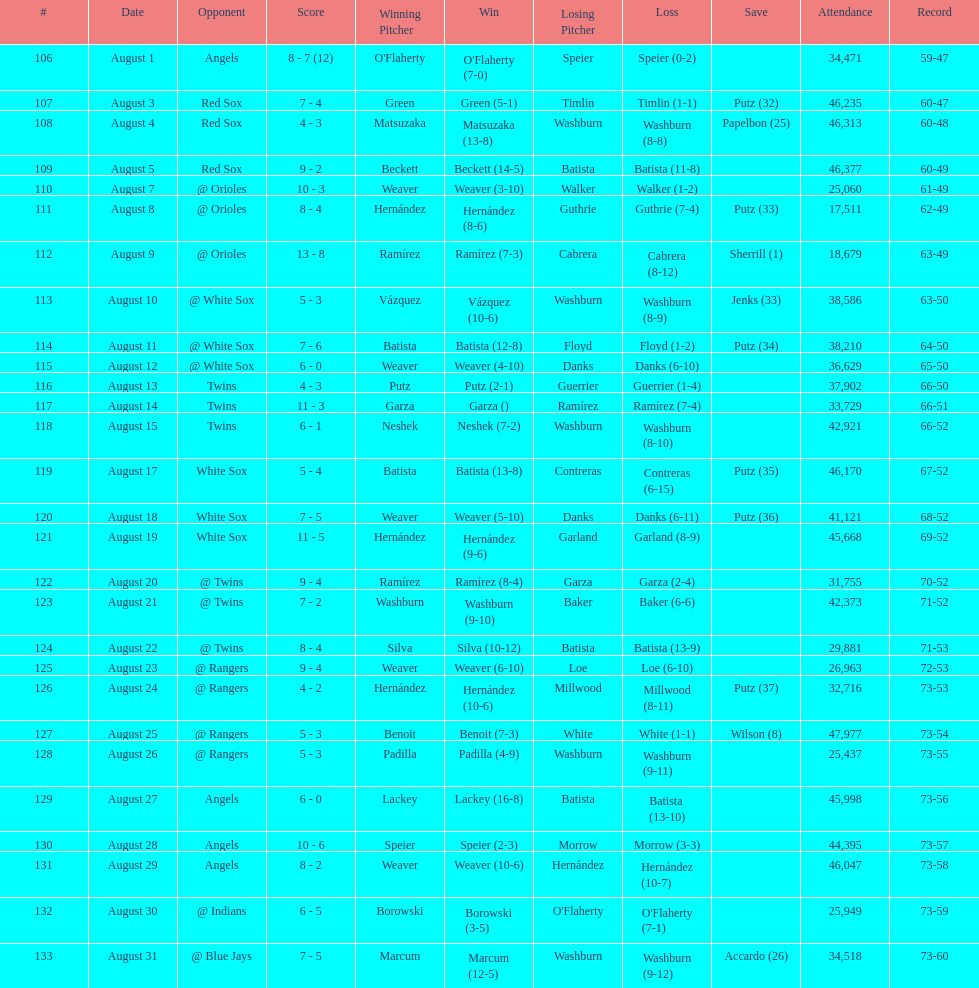Games above 30,000 in attendance 21. 